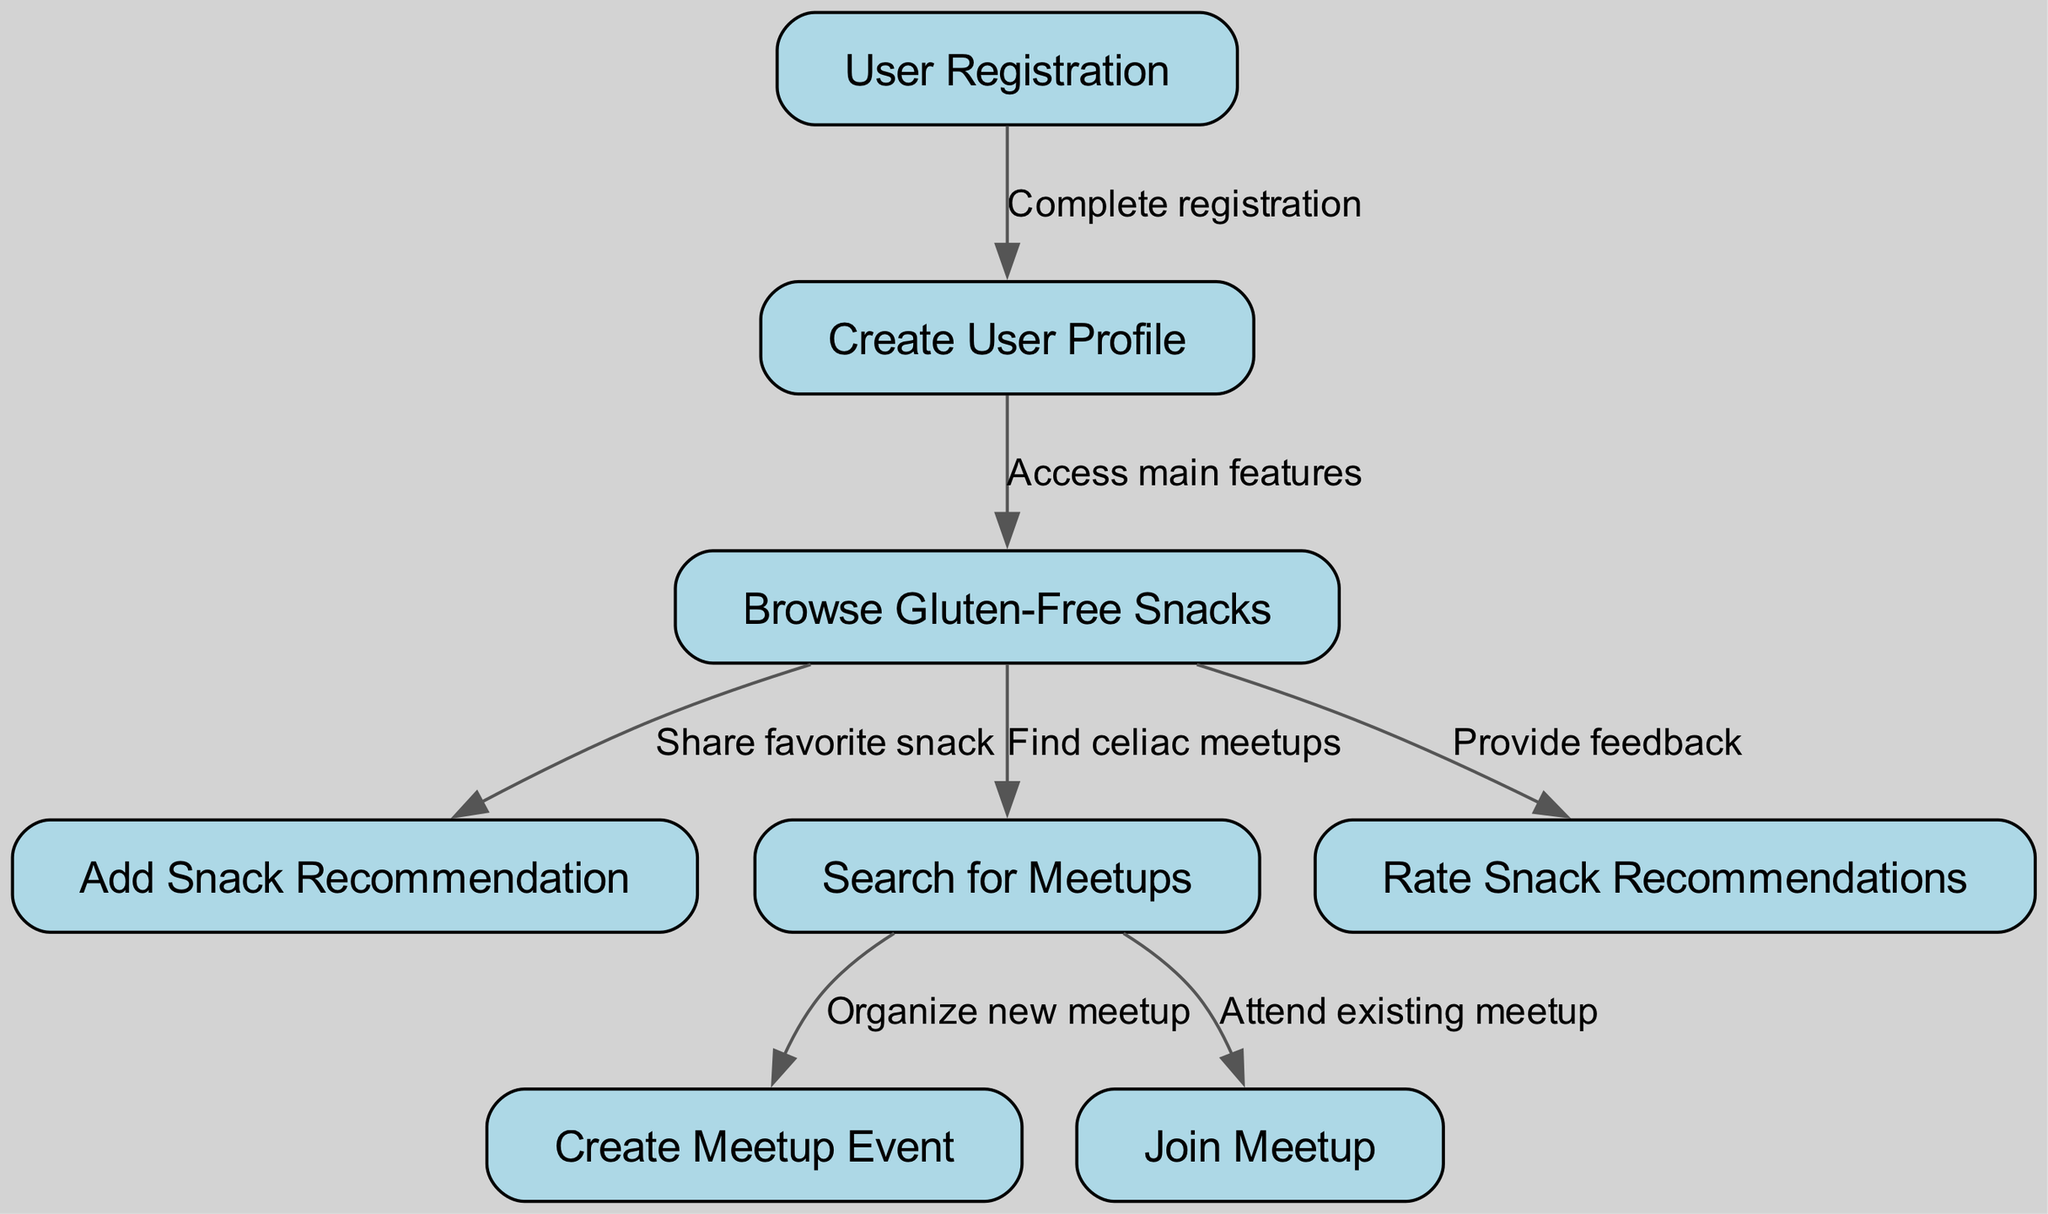What is the first step for a new user in the application? The first step for a new user is "User Registration", as it is the initial node in the flowchart.
Answer: User Registration How many nodes are in the diagram? By counting each node listed under "nodes", there are a total of 8 nodes present in the flowchart.
Answer: 8 What is the last action a user can take after browsing snacks? The last action after "Browse Gluten-Free Snacks" is "Rate Snack Recommendations", as it is directly connected to the browsing node.
Answer: Rate Snack Recommendations What happens after a user completes registration? After completing registration, the flow indicates that the user will "Create User Profile" next, as shown by the directed edge from User Registration to Create User Profile.
Answer: Create User Profile What two actions can a user take after browsing gluten-free snacks? After browsing gluten-free snacks, the user can either "Add Snack Recommendation" or "Search for Meetups", which are both direct connections from the browsing node.
Answer: Add Snack Recommendation, Search for Meetups If a user wants to organize a new meetup, what must they first do? The user must first "Search for Meetups" to proceed to "Create Meetup Event", as the flow shows that organizing a new meetup stems from searching for existing meetups.
Answer: Search for Meetups What is the action that directly follows the "Join Meetup"? There are no subsequent actions leading from "Join Meetup" in the flowchart; it stands alone with no edges extending from it.
Answer: None Which node provides feedback related to snacks? The node "Rate Snack Recommendations" specifically corresponds to providing feedback about different gluten-free snacks in the application.
Answer: Rate Snack Recommendations 